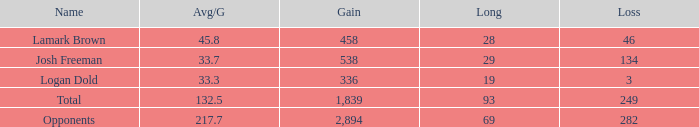Which Avg/G has a Gain of 1,839? 132.5. 